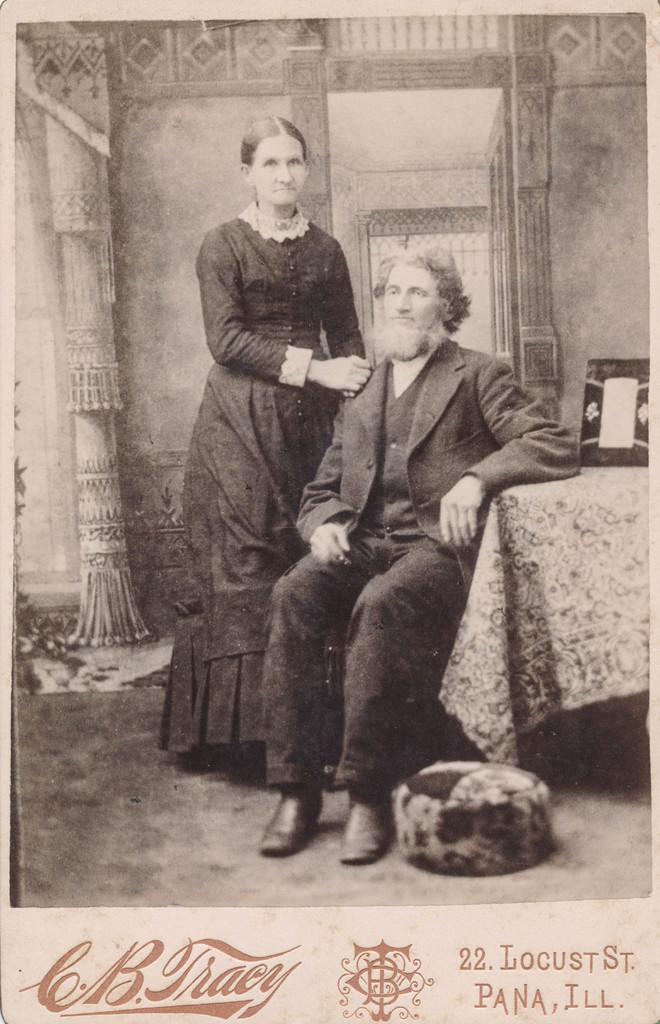Can you describe this image briefly? In the picture we can see a black and white photograph of a man who id sitting on the chair near the table with a tablecloth on it and we can see a photo frame and beside a man we can see a woman standing and she is also wearing a black dress and in the background we can see a wall with some curtains. 